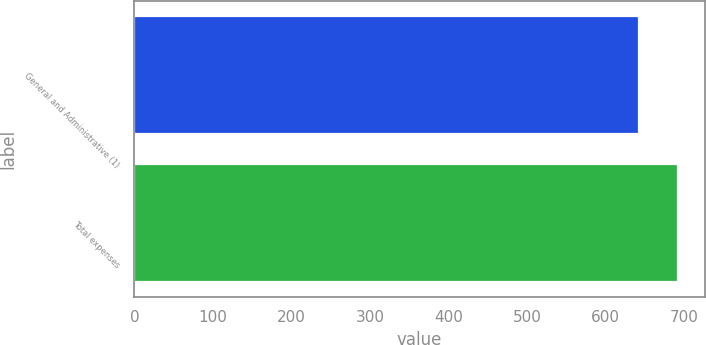<chart> <loc_0><loc_0><loc_500><loc_500><bar_chart><fcel>General and Administrative (1)<fcel>Total expenses<nl><fcel>643<fcel>692<nl></chart> 